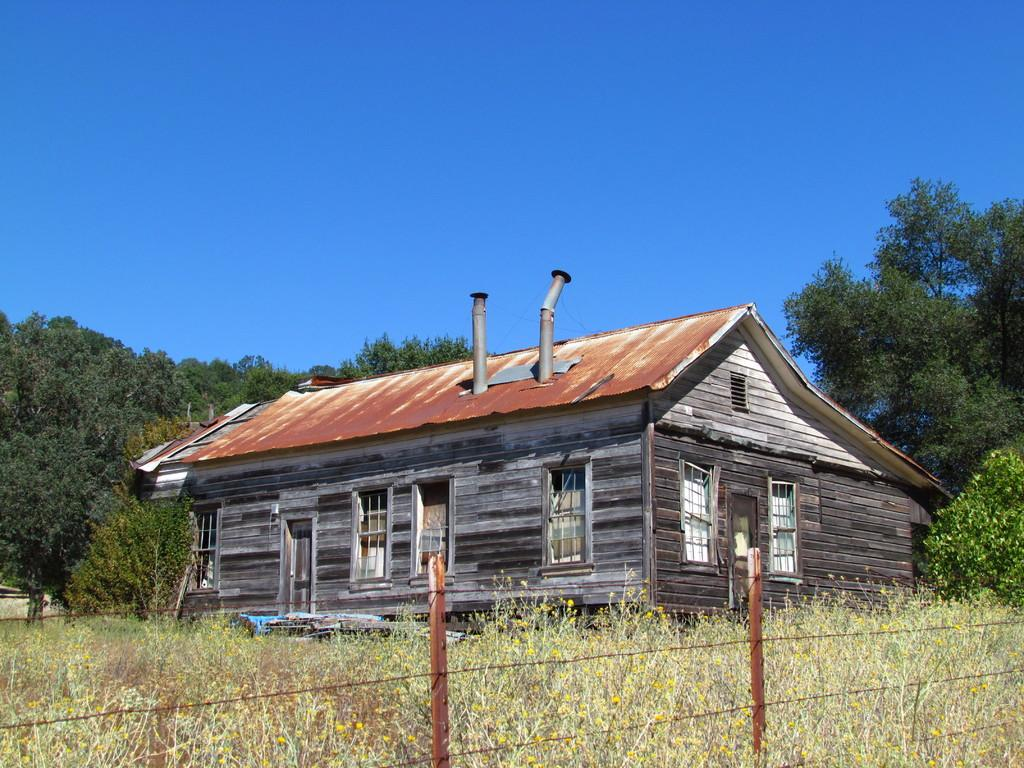What type of house is in the image? There is a wooden house in the image. What can be seen in the background of the image? Trees are visible in the image. What is covering the ground in the image? Grass is present on the ground. What is separating the house from the trees in the image? There is a fence in the image. What color is the sky in the image? The sky is blue in the image. How many matches are being used to light the wooden house in the image? There are no matches present in the image, and the wooden house is not on fire. 